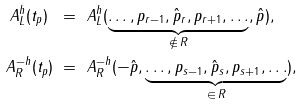<formula> <loc_0><loc_0><loc_500><loc_500>A ^ { h } _ { L } ( t _ { p } ) \ & = \ A ^ { h } _ { L } ( \underbrace { \dots , p _ { r - 1 } , \hat { p } _ { r } , p _ { r + 1 } , \dots } _ { \not \in \, R } , \hat { p } ) , \\ A ^ { - h } _ { R } ( t _ { p } ) \ & = \ A ^ { - h } _ { R } ( - \hat { p } , \underbrace { \dots , p _ { s - 1 } , \hat { p } _ { s } , p _ { s + 1 } , \dots } _ { \in \, R } ) ,</formula> 